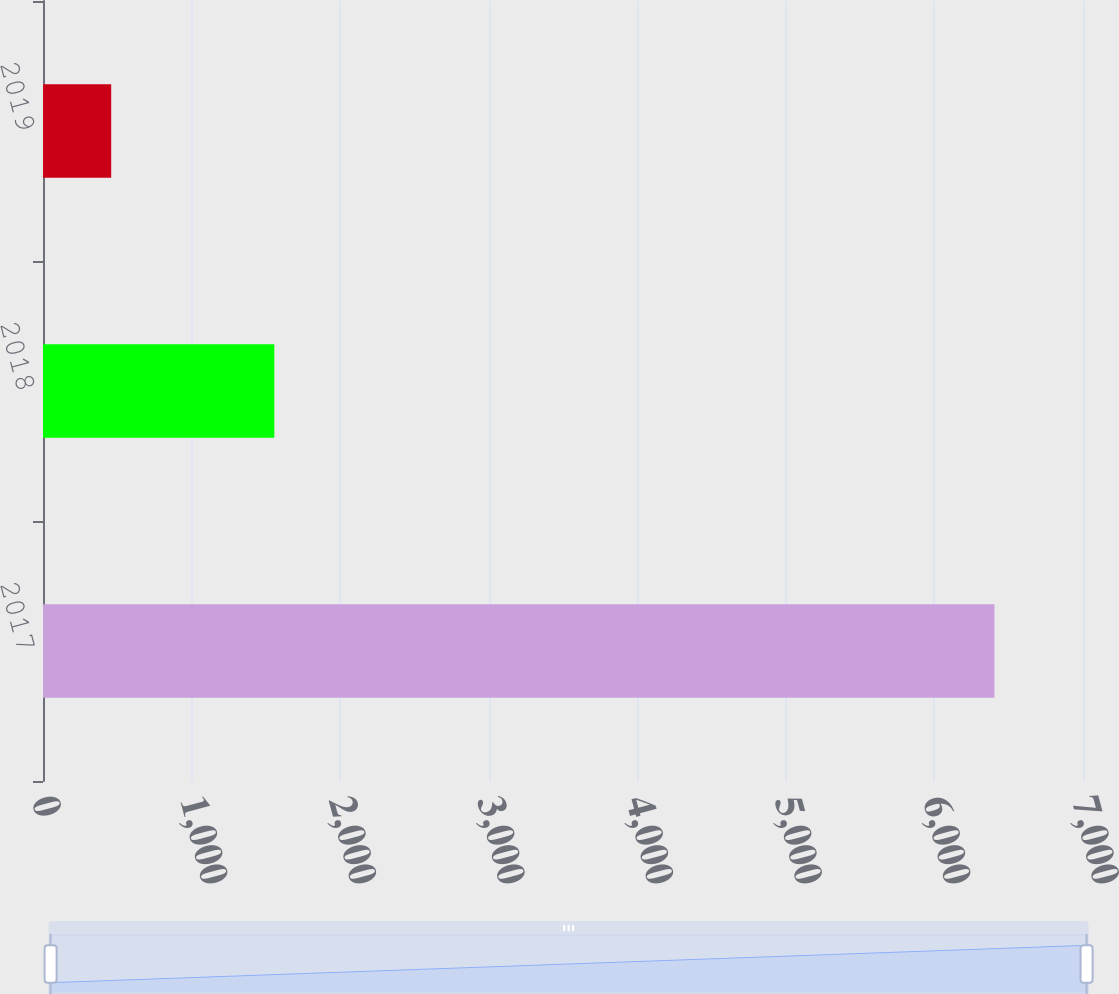Convert chart to OTSL. <chart><loc_0><loc_0><loc_500><loc_500><bar_chart><fcel>2017<fcel>2018<fcel>2019<nl><fcel>6404<fcel>1557<fcel>459<nl></chart> 